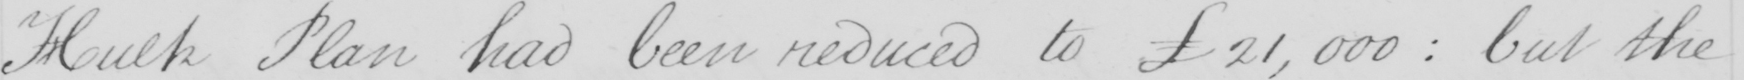What is written in this line of handwriting? Hulk Plan had been reduced to  £21,000 :  but the 